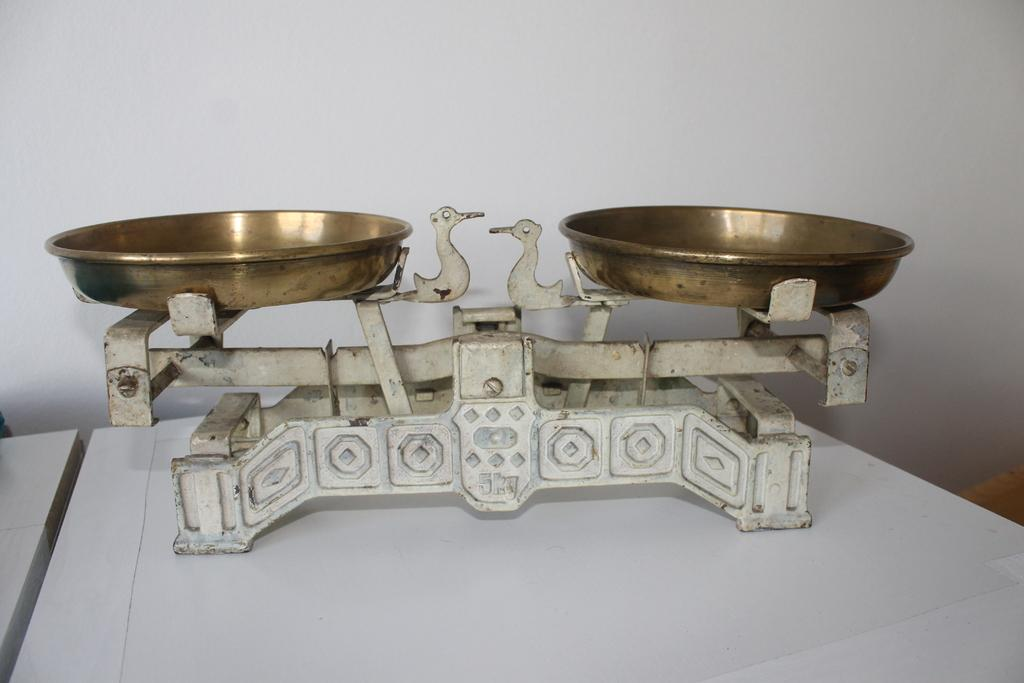What object is the main subject of the image? There is a weighing machine in the image. Where is the weighing machine located? The weighing machine is on a table. What can be seen in the background of the image? There is a wall in the background of the image. What type of grain is being weighed on the machine in the image? There is no grain visible in the image, and the weighing machine is not being used to weigh any grain. 